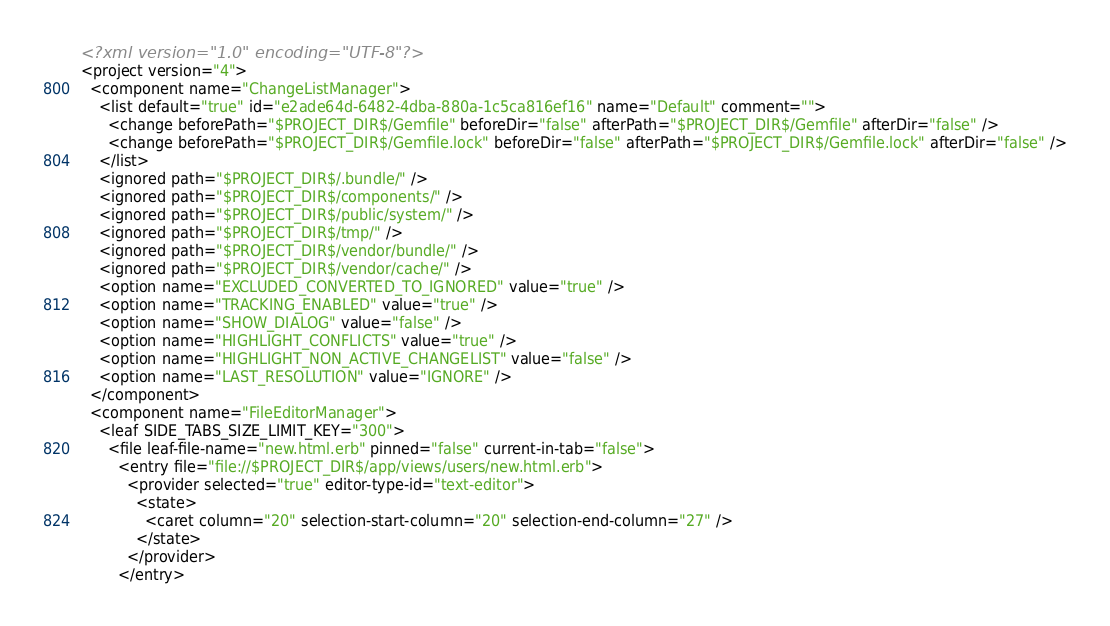<code> <loc_0><loc_0><loc_500><loc_500><_XML_><?xml version="1.0" encoding="UTF-8"?>
<project version="4">
  <component name="ChangeListManager">
    <list default="true" id="e2ade64d-6482-4dba-880a-1c5ca816ef16" name="Default" comment="">
      <change beforePath="$PROJECT_DIR$/Gemfile" beforeDir="false" afterPath="$PROJECT_DIR$/Gemfile" afterDir="false" />
      <change beforePath="$PROJECT_DIR$/Gemfile.lock" beforeDir="false" afterPath="$PROJECT_DIR$/Gemfile.lock" afterDir="false" />
    </list>
    <ignored path="$PROJECT_DIR$/.bundle/" />
    <ignored path="$PROJECT_DIR$/components/" />
    <ignored path="$PROJECT_DIR$/public/system/" />
    <ignored path="$PROJECT_DIR$/tmp/" />
    <ignored path="$PROJECT_DIR$/vendor/bundle/" />
    <ignored path="$PROJECT_DIR$/vendor/cache/" />
    <option name="EXCLUDED_CONVERTED_TO_IGNORED" value="true" />
    <option name="TRACKING_ENABLED" value="true" />
    <option name="SHOW_DIALOG" value="false" />
    <option name="HIGHLIGHT_CONFLICTS" value="true" />
    <option name="HIGHLIGHT_NON_ACTIVE_CHANGELIST" value="false" />
    <option name="LAST_RESOLUTION" value="IGNORE" />
  </component>
  <component name="FileEditorManager">
    <leaf SIDE_TABS_SIZE_LIMIT_KEY="300">
      <file leaf-file-name="new.html.erb" pinned="false" current-in-tab="false">
        <entry file="file://$PROJECT_DIR$/app/views/users/new.html.erb">
          <provider selected="true" editor-type-id="text-editor">
            <state>
              <caret column="20" selection-start-column="20" selection-end-column="27" />
            </state>
          </provider>
        </entry></code> 